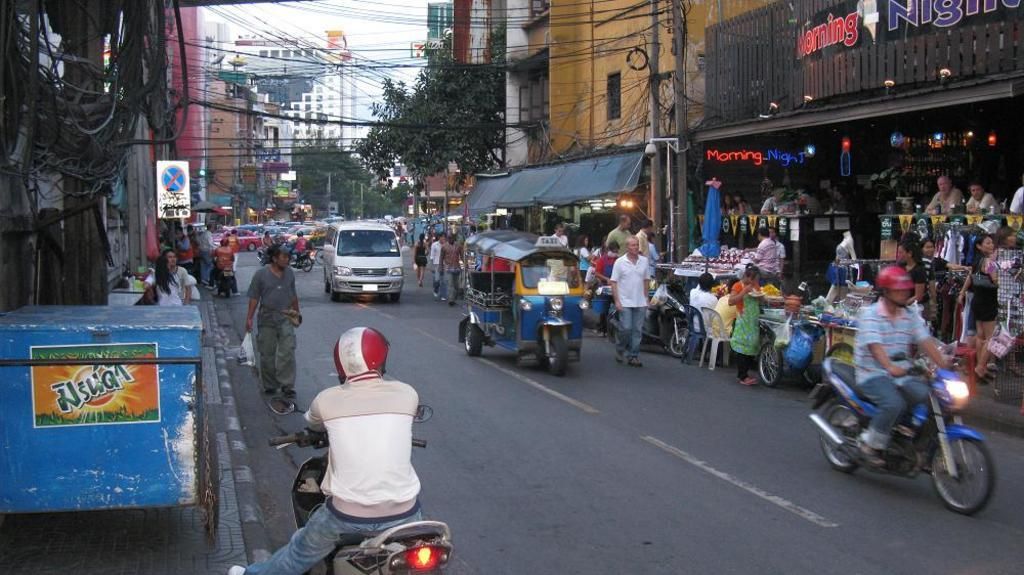What is happening on the road in the image? Vehicles are passing on a road in the image. What are the people doing near the road? There are people walking on a footpath in the image. What type of establishment is located beside the road? There is a store beside the road in the image. What can be seen in the background of the image? There are buildings and cables visible in the background of the image. How many pigs are sleeping on the beds in the image? There are no pigs or beds present in the image. What is the head of the person walking on the footpath doing in the image? There is no specific information about the head of the person walking on the footpath in the image. 